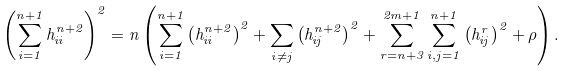Convert formula to latex. <formula><loc_0><loc_0><loc_500><loc_500>\left ( \sum _ { i = 1 } ^ { n + 1 } h _ { i i } ^ { n + 2 } \right ) ^ { 2 } = n \left ( \sum _ { i = 1 } ^ { n + 1 } \left ( h _ { i i } ^ { n + 2 } \right ) ^ { 2 } + \sum _ { i \not { = } j } \left ( h _ { i j } ^ { n + 2 } \right ) ^ { 2 } + \sum _ { r = { n + 3 } } ^ { 2 m + 1 } \sum _ { i , j = 1 } ^ { n + 1 } \left ( h _ { i j } ^ { r } \right ) ^ { 2 } + \rho \right ) .</formula> 